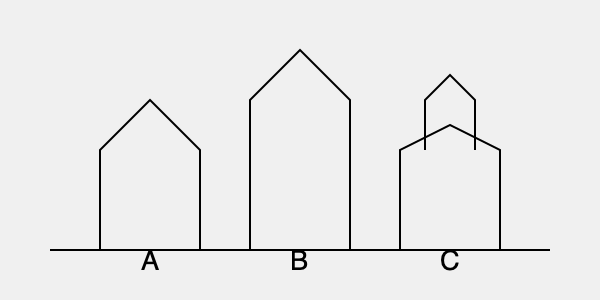Based on the silhouette diagrams of three Baltic churches shown above, which architectural style is most likely represented by Church B? To determine the architectural style of Church B, let's analyze the silhouettes step-by-step:

1. Church A: 
   - Has a simple triangular roof
   - Represents a basic church design, possibly Romanesque or early Gothic

2. Church B:
   - Features a tall, pointed spire
   - Has a steep, triangular roof
   - The overall shape is elongated and vertical
   - These characteristics are typical of Gothic architecture

3. Church C:
   - Has a main triangular roof
   - Features a smaller triangular structure on top
   - This design is reminiscent of Baroque or later styles with more complex roof structures

Comparing these, Church B stands out with its emphasis on height and pointed features. The tall spire and steep roof are hallmarks of Gothic architecture, which was prevalent in many Baltic countries during the medieval period. Gothic churches were designed to draw the eye upward, symbolizing a connection between earth and heaven.

In the context of Baltic architecture, many churches built during the 13th to 16th centuries adopted Gothic styles, particularly in countries like Latvia and Estonia. The silhouette of Church B closely resembles that of famous Gothic churches in the region, such as St. Olaf's Church in Tallinn, Estonia.
Answer: Gothic 